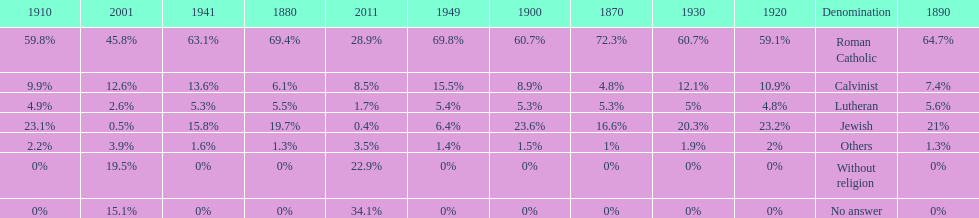How many denominations never dropped below 20%? 1. 